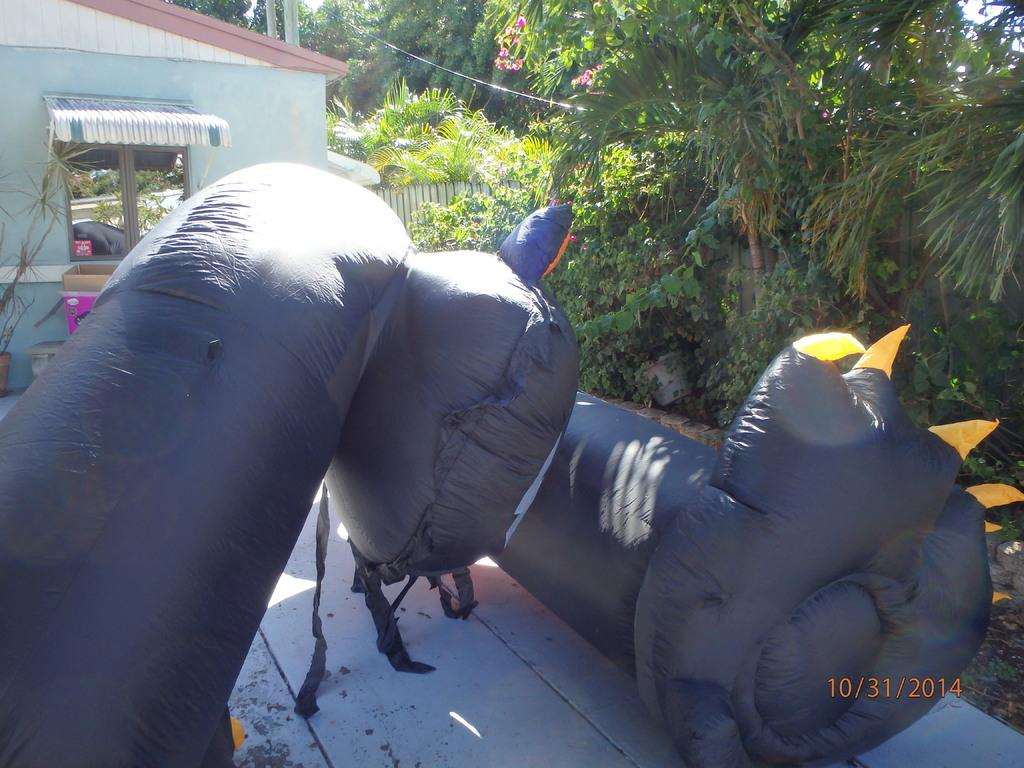What is located on the ground in the image? There is an inflatable on the ground in the image. What can be seen in the background of the image? There is a house, trees, and fencing in the background of the image. Is there any indication of the date in the image? Yes, the date is visible in the bottom right corner of the image. Can you see any fairies flying around the inflatable in the image? There are no fairies present in the image. What type of sweater is the inflatable wearing in the image? The inflatable is not a person and does not wear clothing, so it is not wearing a sweater in the image. 